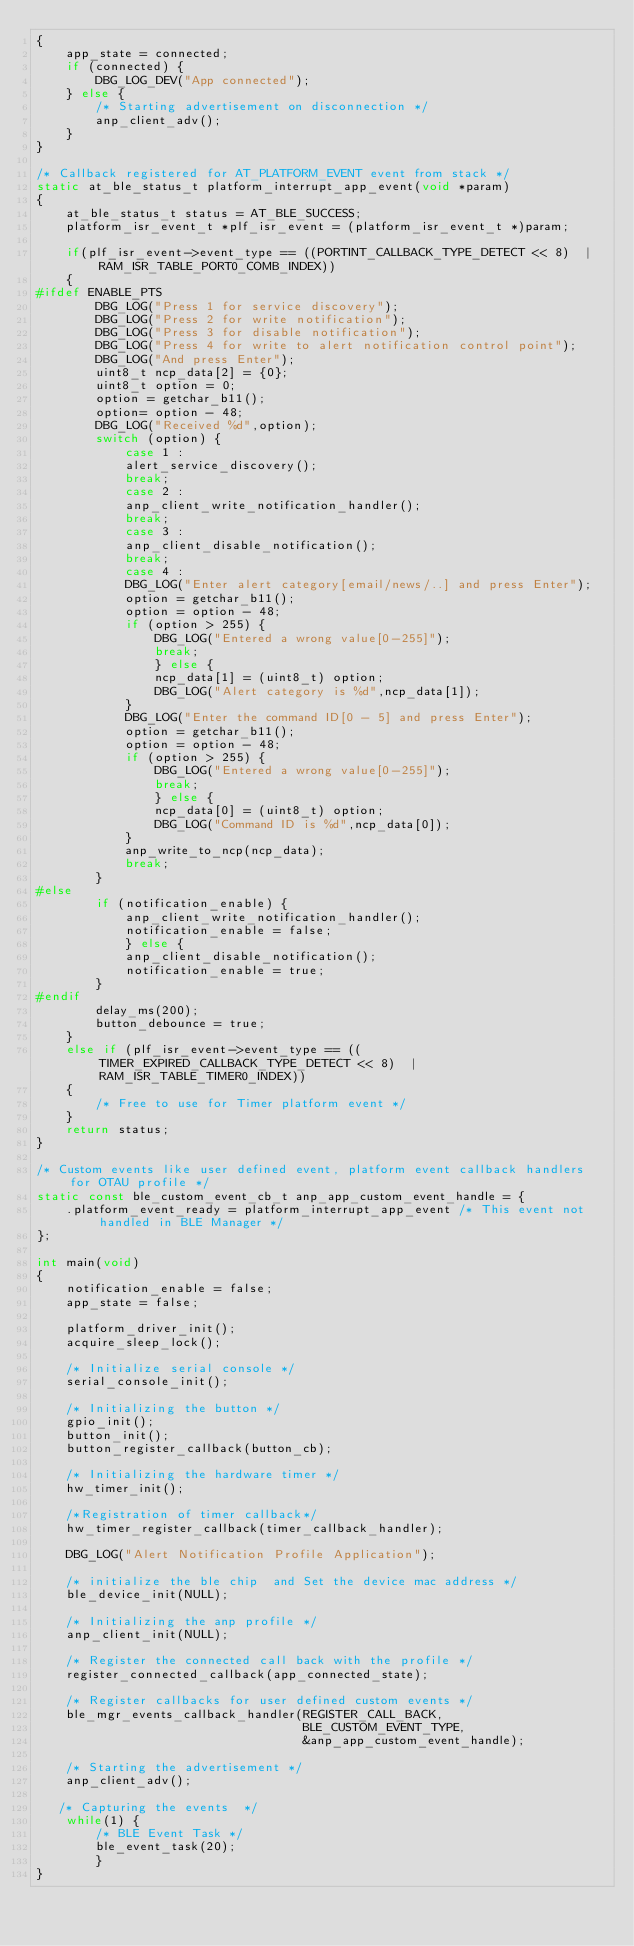<code> <loc_0><loc_0><loc_500><loc_500><_C_>{
	app_state = connected;
	if (connected) {
		DBG_LOG_DEV("App connected");	
	} else {
		/* Starting advertisement on disconnection */
		anp_client_adv();
	}		
}

/* Callback registered for AT_PLATFORM_EVENT event from stack */
static at_ble_status_t platform_interrupt_app_event(void *param)
{
	at_ble_status_t status = AT_BLE_SUCCESS;
	platform_isr_event_t *plf_isr_event = (platform_isr_event_t *)param;
	
	if(plf_isr_event->event_type == ((PORTINT_CALLBACK_TYPE_DETECT << 8)  | RAM_ISR_TABLE_PORT0_COMB_INDEX))
	{
#ifdef ENABLE_PTS
		DBG_LOG("Press 1 for service discovery");
		DBG_LOG("Press 2 for write notification");
		DBG_LOG("Press 3 for disable notification");
		DBG_LOG("Press 4 for write to alert notification control point");
		DBG_LOG("And press Enter");
		uint8_t ncp_data[2] = {0};
		uint8_t option = 0;
		option = getchar_b11();
		option= option - 48;
		DBG_LOG("Received %d",option);
		switch (option) {
			case 1 :
			alert_service_discovery();
			break;
			case 2 :
			anp_client_write_notification_handler();
			break;
			case 3 :
			anp_client_disable_notification();
			break;
			case 4 :
			DBG_LOG("Enter alert category[email/news/..] and press Enter");
			option = getchar_b11();
			option = option - 48;
			if (option > 255) {
				DBG_LOG("Entered a wrong value[0-255]");
				break;
				} else {
				ncp_data[1] = (uint8_t) option;
				DBG_LOG("Alert category is %d",ncp_data[1]);
			}
			DBG_LOG("Enter the command ID[0 - 5] and press Enter");
			option = getchar_b11();
			option = option - 48;
			if (option > 255) {
				DBG_LOG("Entered a wrong value[0-255]");
				break;
				} else {
				ncp_data[0] = (uint8_t) option;
				DBG_LOG("Command ID is %d",ncp_data[0]);
			}
			anp_write_to_ncp(ncp_data);
			break;
		}
#else
		if (notification_enable) {
			anp_client_write_notification_handler();
			notification_enable = false;
			} else {
			anp_client_disable_notification();
			notification_enable = true;
		}
#endif
		delay_ms(200);
		button_debounce = true;
	}
	else if (plf_isr_event->event_type == ((TIMER_EXPIRED_CALLBACK_TYPE_DETECT << 8)  | RAM_ISR_TABLE_TIMER0_INDEX))
	{
		/* Free to use for Timer platform event */
	}
	return status;
}

/* Custom events like user defined event, platform event callback handlers for OTAU profile */
static const ble_custom_event_cb_t anp_app_custom_event_handle = {
	.platform_event_ready = platform_interrupt_app_event /* This event not handled in BLE Manager */
};

int main(void)
{
	notification_enable = false;
	app_state = false;

	platform_driver_init();
	acquire_sleep_lock();

	/* Initialize serial console */
	serial_console_init();

	/* Initializing the button */
	gpio_init();
	button_init();
	button_register_callback(button_cb);
	
	/* Initializing the hardware timer */
	hw_timer_init();
	
	/*Registration of timer callback*/
	hw_timer_register_callback(timer_callback_handler);
	
	DBG_LOG("Alert Notification Profile Application");
	
	/* initialize the ble chip  and Set the device mac address */
	ble_device_init(NULL);
	
	/* Initializing the anp profile */
	anp_client_init(NULL);

	/* Register the connected call back with the profile */
	register_connected_callback(app_connected_state);
	
	/* Register callbacks for user defined custom events */
	ble_mgr_events_callback_handler(REGISTER_CALL_BACK,
									BLE_CUSTOM_EVENT_TYPE,
									&anp_app_custom_event_handle);
	
	/* Starting the advertisement */
	anp_client_adv();
	
   /* Capturing the events  */
	while(1) {
		/* BLE Event Task */
		ble_event_task(20);
		}
}
</code> 